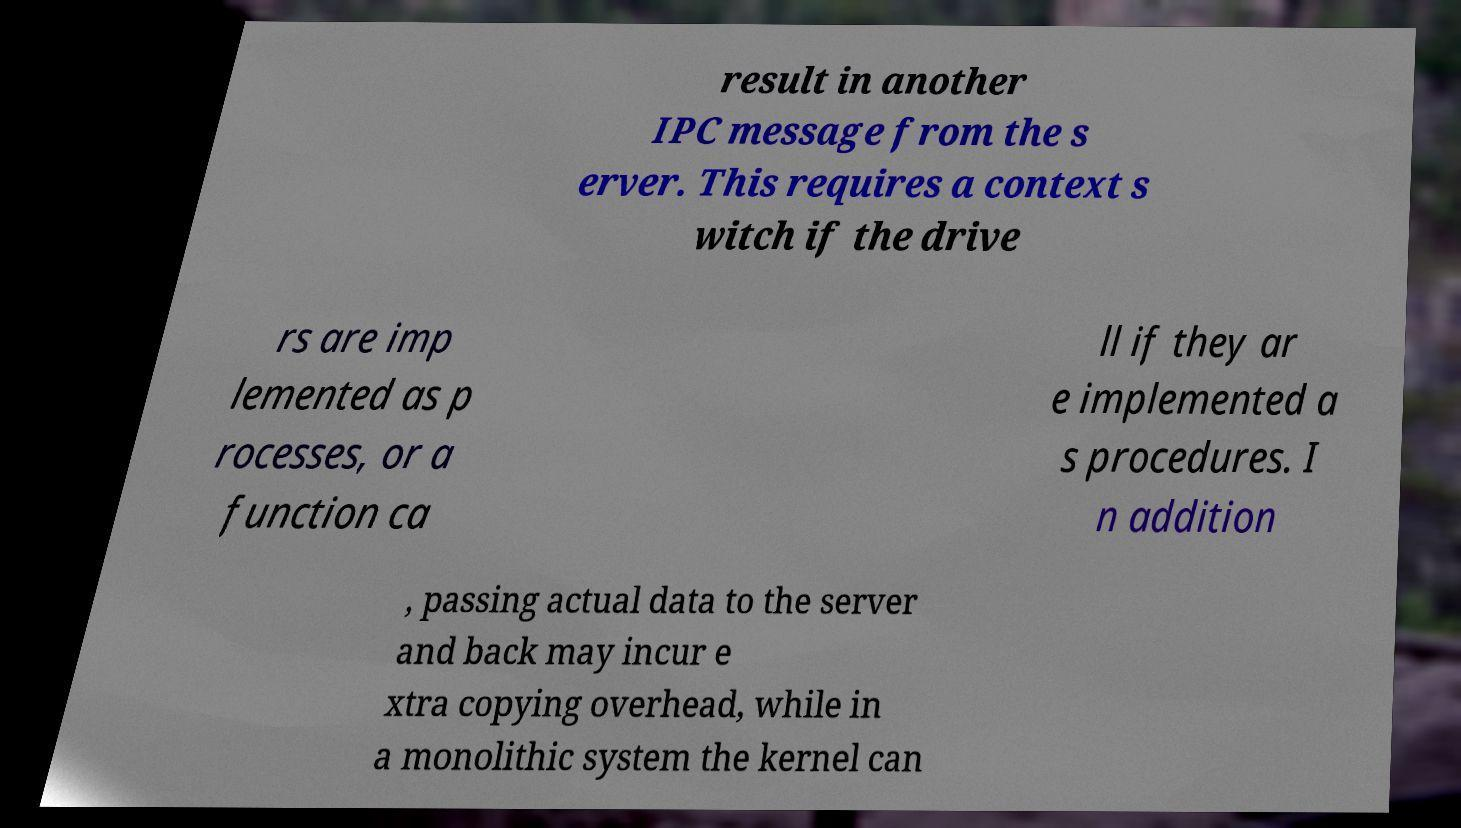Can you accurately transcribe the text from the provided image for me? result in another IPC message from the s erver. This requires a context s witch if the drive rs are imp lemented as p rocesses, or a function ca ll if they ar e implemented a s procedures. I n addition , passing actual data to the server and back may incur e xtra copying overhead, while in a monolithic system the kernel can 